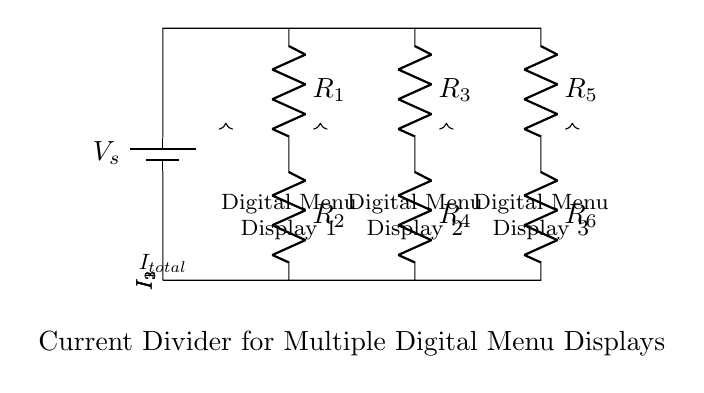What is the supply voltage in this circuit? The supply voltage, labeled as \( V_s \), is typically the voltage source required for the whole circuit. While it is not given a specific value in the diagram, it is essential for providing power to the menu displays.
Answer: V_s How many digital menu displays are shown in the circuit? There are three digital menu displays indicated in the circuit diagram, as labeled clearly as "Digital Menu Display 1," "Digital Menu Display 2," and "Digital Menu Display 3."
Answer: 3 What is the resistance value of the first resistor? The first resistor in the circuit is labeled as \( R_1 \). The exact value is not provided in the diagram, but it is significant as the current divider distributes total current based on the resistance values.
Answer: R_1 How is the total current split among the displays? The total current \( I_{total} \) enters the circuit and splits into three paths leading to the digital menu displays, with each path's current determined by the respective resistance values (according to Ohm's law).
Answer: By resistance values Which display would receive the highest current? The digital menu display receiving the highest current is determined by the lowest resistance path. If \( R_2 \) has the lowest value among its counterparts, it would draw the most current. The specific answer depends on the resistance values given in a practical scenario.
Answer: Display with lowest resistance In a current divider, how does the resistor value affect the current distribution? In a current divider configuration, the current flowing through each resistor is inversely proportional to its resistance value. Lower resistance will yield higher current, while higher resistance will receive lesser current. Thus, this relationship governs how currents divide among the menu displays.
Answer: Inversely proportional What happens if one of the displays is disconnected? If one of the displays is disconnected, the total current will be redistributed among the remaining displays. This could potentially increase the current through those that are still connected, depending on their resistance values.
Answer: Redistributed current 